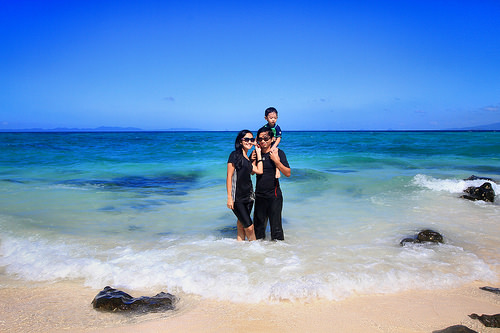<image>
Is the women on the water? Yes. Looking at the image, I can see the women is positioned on top of the water, with the water providing support. 